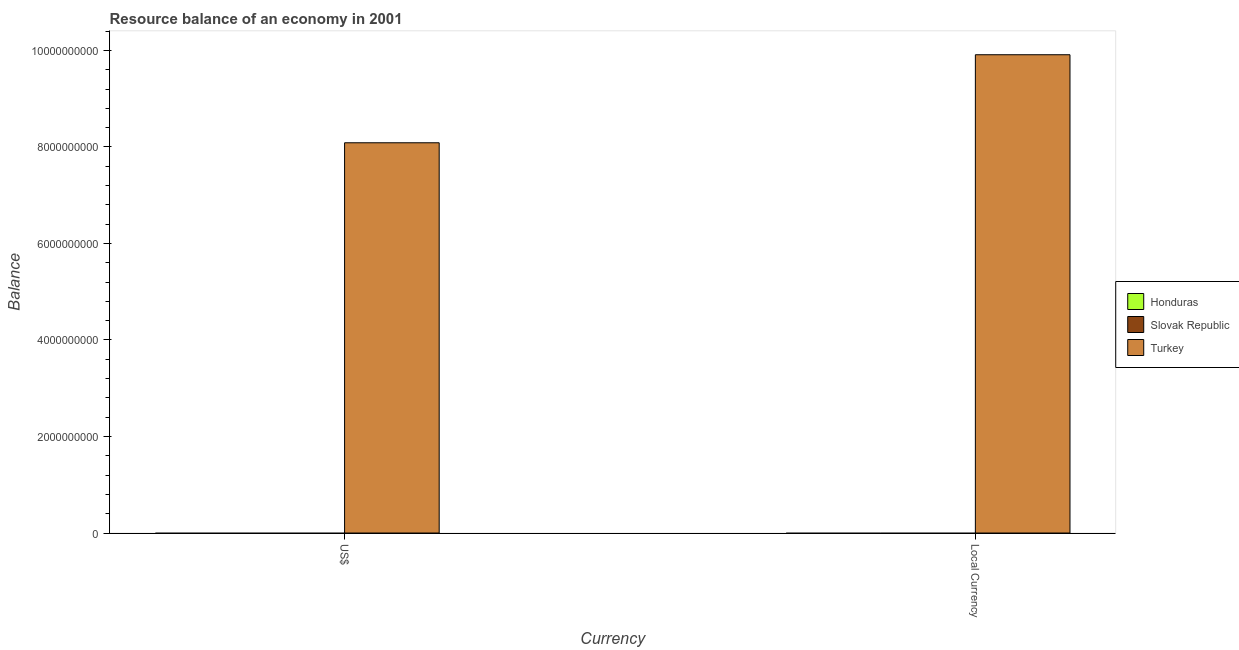How many bars are there on the 2nd tick from the right?
Offer a terse response. 1. What is the label of the 2nd group of bars from the left?
Your answer should be compact. Local Currency. Across all countries, what is the maximum resource balance in constant us$?
Your answer should be very brief. 9.91e+09. Across all countries, what is the minimum resource balance in constant us$?
Make the answer very short. 0. What is the total resource balance in us$ in the graph?
Your answer should be very brief. 8.09e+09. What is the difference between the resource balance in constant us$ in Turkey and the resource balance in us$ in Honduras?
Make the answer very short. 9.91e+09. What is the average resource balance in constant us$ per country?
Provide a succinct answer. 3.30e+09. What is the difference between the resource balance in constant us$ and resource balance in us$ in Turkey?
Provide a short and direct response. 1.82e+09. In how many countries, is the resource balance in us$ greater than 800000000 units?
Your response must be concise. 1. In how many countries, is the resource balance in us$ greater than the average resource balance in us$ taken over all countries?
Offer a terse response. 1. How many bars are there?
Provide a short and direct response. 2. How many countries are there in the graph?
Offer a very short reply. 3. What is the difference between two consecutive major ticks on the Y-axis?
Offer a terse response. 2.00e+09. Are the values on the major ticks of Y-axis written in scientific E-notation?
Your response must be concise. No. How are the legend labels stacked?
Offer a very short reply. Vertical. What is the title of the graph?
Offer a very short reply. Resource balance of an economy in 2001. What is the label or title of the X-axis?
Give a very brief answer. Currency. What is the label or title of the Y-axis?
Your response must be concise. Balance. What is the Balance of Honduras in US$?
Your answer should be very brief. 0. What is the Balance of Slovak Republic in US$?
Your response must be concise. 0. What is the Balance of Turkey in US$?
Keep it short and to the point. 8.09e+09. What is the Balance of Turkey in Local Currency?
Provide a short and direct response. 9.91e+09. Across all Currency, what is the maximum Balance of Turkey?
Keep it short and to the point. 9.91e+09. Across all Currency, what is the minimum Balance in Turkey?
Keep it short and to the point. 8.09e+09. What is the total Balance of Honduras in the graph?
Your answer should be very brief. 0. What is the total Balance of Turkey in the graph?
Your answer should be compact. 1.80e+1. What is the difference between the Balance in Turkey in US$ and that in Local Currency?
Provide a succinct answer. -1.82e+09. What is the average Balance of Honduras per Currency?
Give a very brief answer. 0. What is the average Balance of Turkey per Currency?
Your answer should be compact. 9.00e+09. What is the ratio of the Balance in Turkey in US$ to that in Local Currency?
Provide a short and direct response. 0.82. What is the difference between the highest and the second highest Balance of Turkey?
Provide a succinct answer. 1.82e+09. What is the difference between the highest and the lowest Balance of Turkey?
Keep it short and to the point. 1.82e+09. 